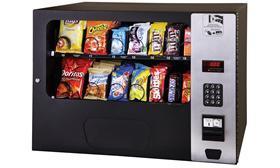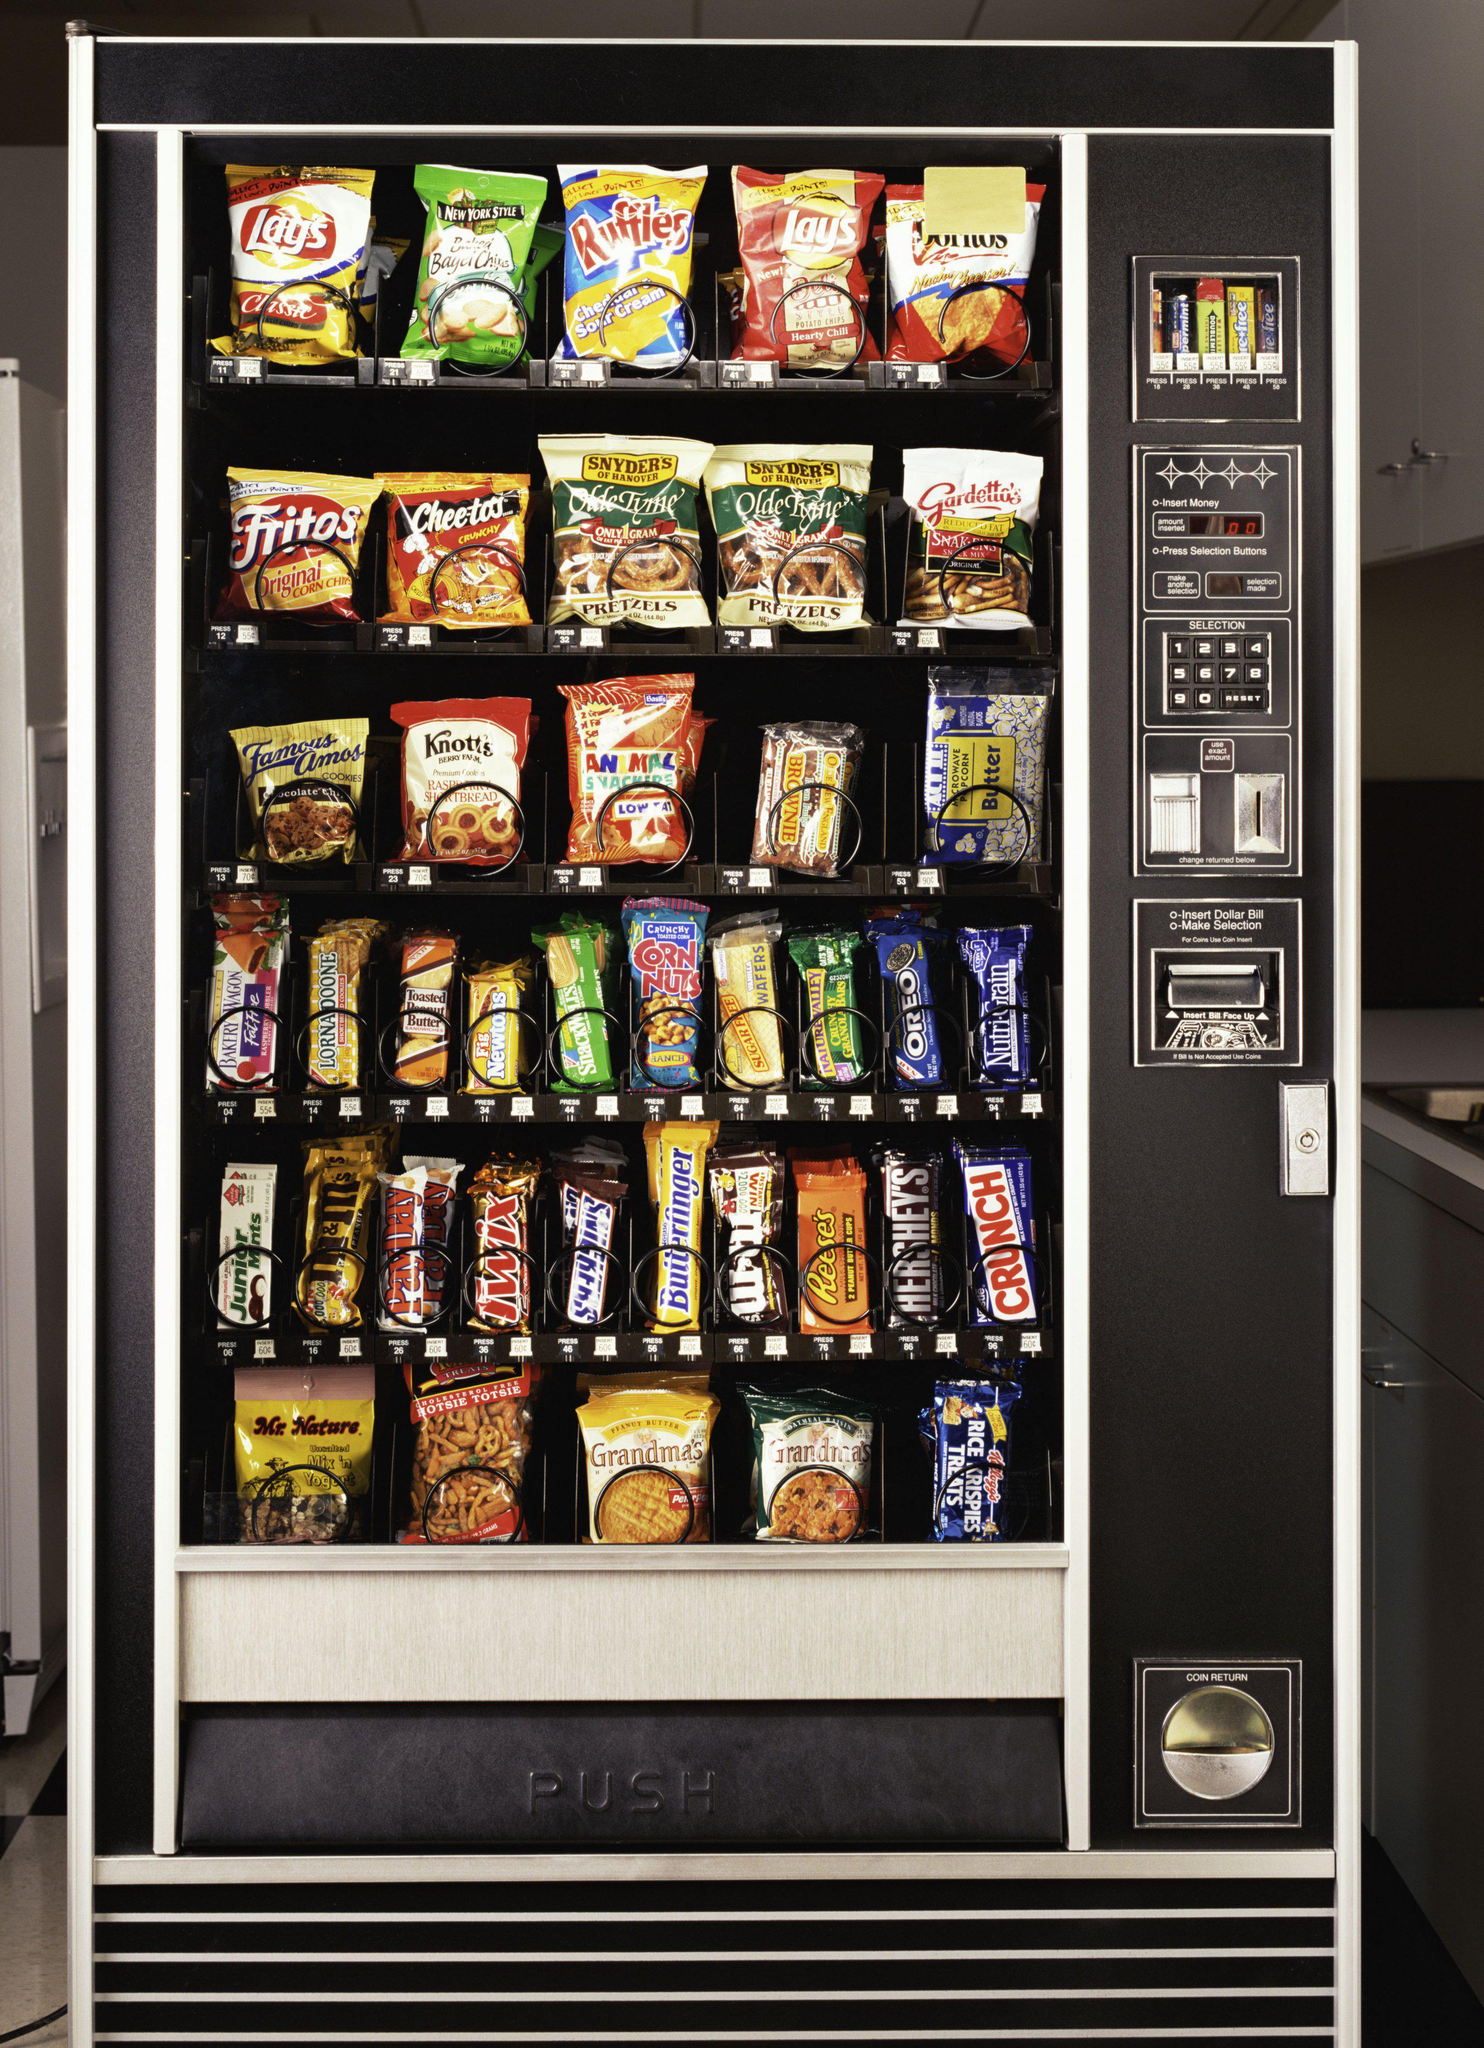The first image is the image on the left, the second image is the image on the right. Given the left and right images, does the statement "A bank of four vending machines is shown in one image." hold true? Answer yes or no. No. 